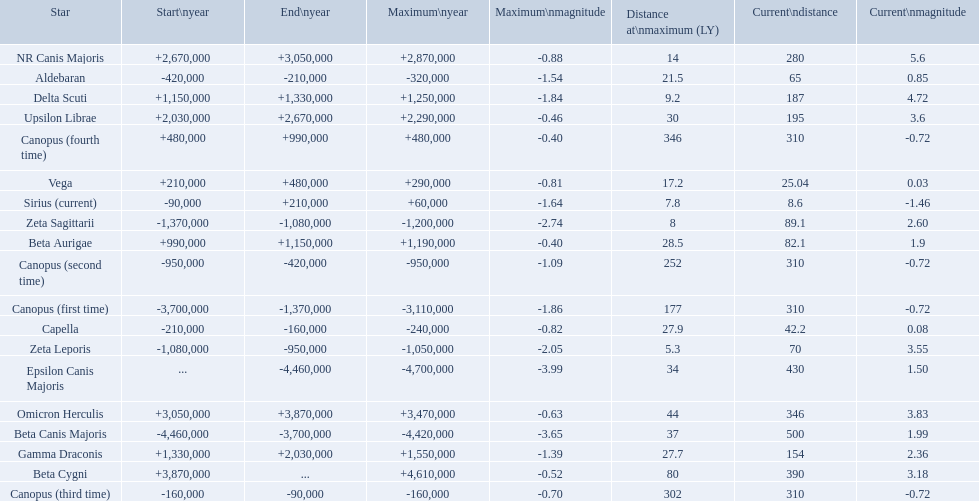What are the historical brightest stars? Epsilon Canis Majoris, Beta Canis Majoris, Canopus (first time), Zeta Sagittarii, Zeta Leporis, Canopus (second time), Aldebaran, Capella, Canopus (third time), Sirius (current), Vega, Canopus (fourth time), Beta Aurigae, Delta Scuti, Gamma Draconis, Upsilon Librae, NR Canis Majoris, Omicron Herculis, Beta Cygni. Of those which star has a distance at maximum of 80 Beta Cygni. What star has a a maximum magnitude of -0.63. Omicron Herculis. What star has a current distance of 390? Beta Cygni. 